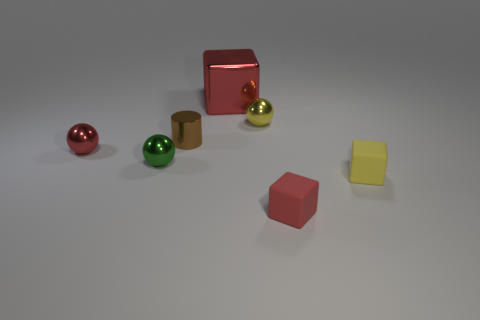Subtract all yellow matte cubes. How many cubes are left? 2 Subtract all red cylinders. How many red cubes are left? 2 Subtract 1 spheres. How many spheres are left? 2 Add 2 green rubber spheres. How many objects exist? 9 Subtract all cyan balls. Subtract all red cylinders. How many balls are left? 3 Subtract all cylinders. How many objects are left? 6 Subtract all big green cylinders. Subtract all yellow matte objects. How many objects are left? 6 Add 2 large cubes. How many large cubes are left? 3 Add 2 small brown metal blocks. How many small brown metal blocks exist? 2 Subtract 1 green spheres. How many objects are left? 6 